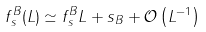<formula> <loc_0><loc_0><loc_500><loc_500>f ^ { B } _ { s } ( L ) \simeq f ^ { B } _ { s } L + s _ { B } + \mathcal { O } \left ( L ^ { - 1 } \right )</formula> 